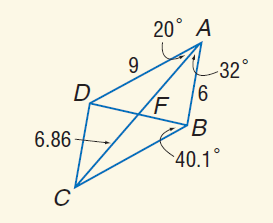Answer the mathemtical geometry problem and directly provide the correct option letter.
Question: Use parallelogram A B C D to find C D.
Choices: A: 6 B: 9 C: 12 D: 18 A 